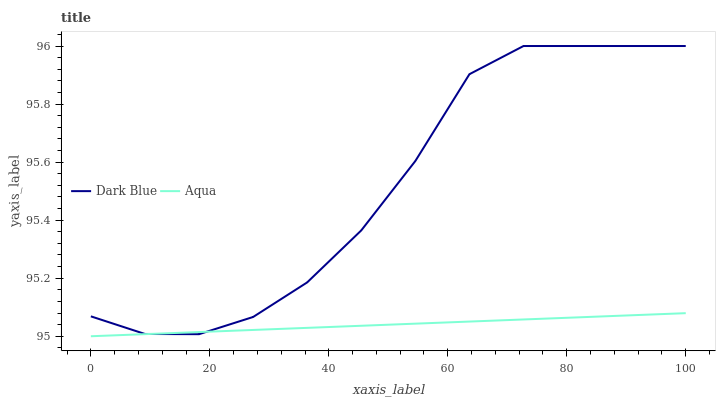Does Aqua have the minimum area under the curve?
Answer yes or no. Yes. Does Dark Blue have the maximum area under the curve?
Answer yes or no. Yes. Does Aqua have the maximum area under the curve?
Answer yes or no. No. Is Aqua the smoothest?
Answer yes or no. Yes. Is Dark Blue the roughest?
Answer yes or no. Yes. Is Aqua the roughest?
Answer yes or no. No. Does Aqua have the highest value?
Answer yes or no. No. 